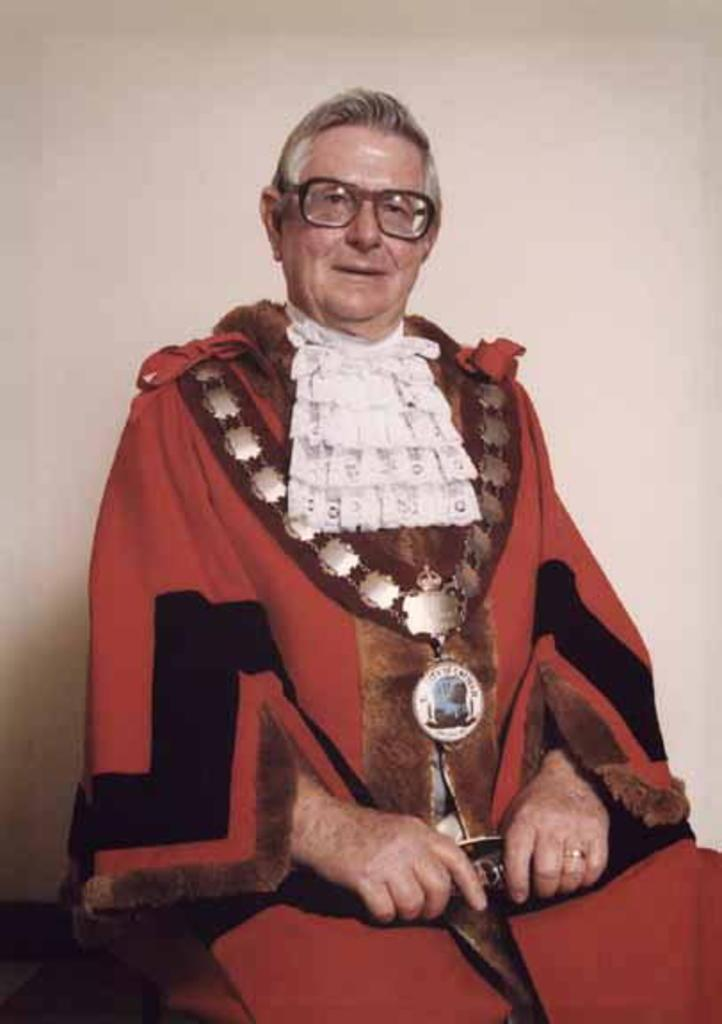Who is present in the image? There is a person in the image. What can be observed about the person's appearance? The person is wearing spectacles. What is the person doing with their hand? The person is holding an object in their hand. What is the person's posture in the image? The person is sitting. What can be seen in the background of the image? There is a wall in the background of the image. What statement is the person making in the image? There is no statement being made by the person in the image. What is the person writing in the image? The person is not writing anything in the image. How does the person's digestion appear to be in the image? There is no indication of the person's digestion in the image. 